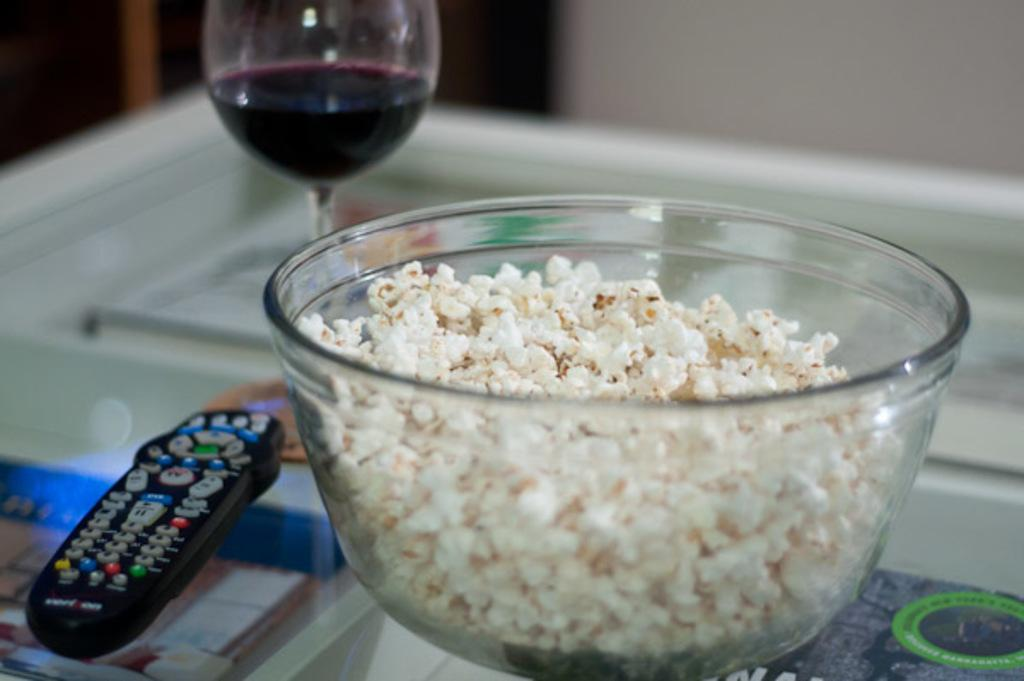What piece of furniture is visible in the image? There is a table in the image. What object related to electronic devices can be seen on the table? A remote is present on the table. What type of container is on the table? There is a glass and a bowl on the table. What is inside the bowl on the table? The bowl contains popcorn. How would you describe the background of the image? The background of the image is blurred. How many bikes are parked next to the table in the image? There are no bikes present in the image; it only features a table with various objects on it. What type of magic trick is being performed in the image? There is no magic trick being performed in the image; it is a simple scene with a table and various objects on it. 